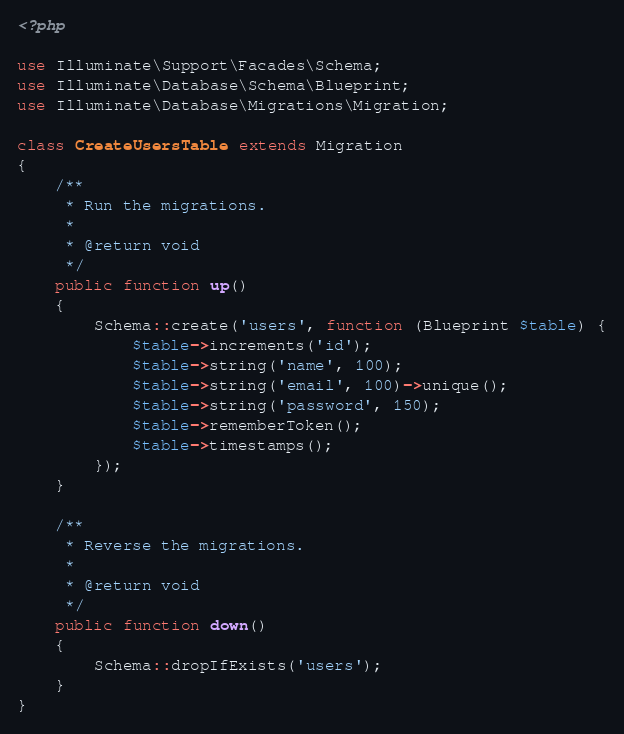<code> <loc_0><loc_0><loc_500><loc_500><_PHP_><?php

use Illuminate\Support\Facades\Schema;
use Illuminate\Database\Schema\Blueprint;
use Illuminate\Database\Migrations\Migration;

class CreateUsersTable extends Migration
{
    /**
     * Run the migrations.
     *
     * @return void
     */
    public function up()
    {
        Schema::create('users', function (Blueprint $table) {
            $table->increments('id');
            $table->string('name', 100);
            $table->string('email', 100)->unique();
            $table->string('password', 150);
            $table->rememberToken();
            $table->timestamps();
        });
    }

    /**
     * Reverse the migrations.
     *
     * @return void
     */
    public function down()
    {
        Schema::dropIfExists('users');
    }
}
</code> 